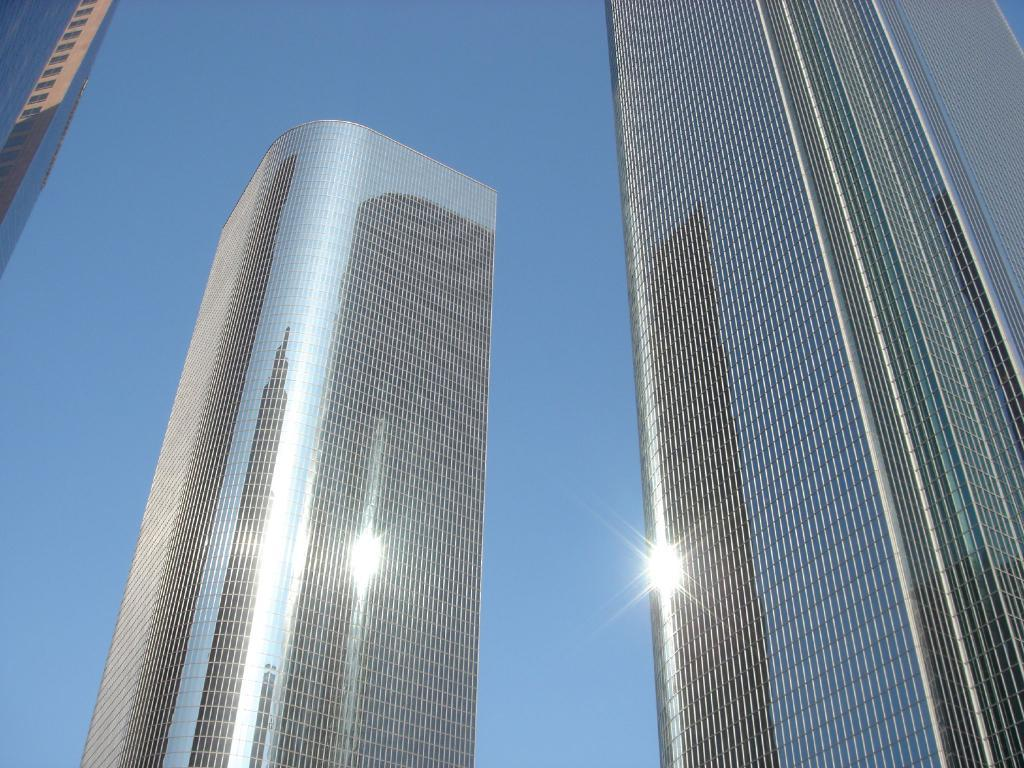How many tall buildings can be seen in the image? There are three tall buildings in the image. What else can be seen in the image besides the buildings? The sky is visible in the image. Are there any ants crawling on the buildings in the image? There are no ants visible in the image; it only features tall buildings and the sky. What type of vegetable can be seen growing on the buildings in the image? There are no vegetables present in the image; it only features tall buildings and the sky. 